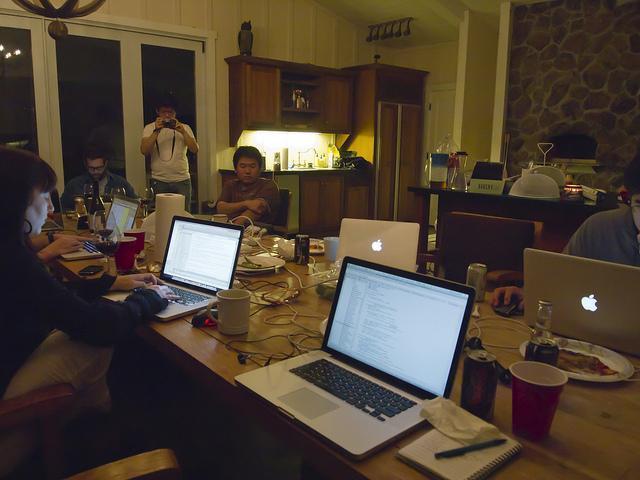What type of animal can be seen on top of the shelf near the back doors?
Make your selection from the four choices given to correctly answer the question.
Options: Pigeon, eagle, owl, hawk. Owl. 